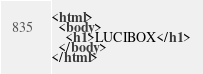Convert code to text. <code><loc_0><loc_0><loc_500><loc_500><_HTML_><html>
  <body>
    <h1>LUCIBOX</h1>
  </body>
</html>
</code> 